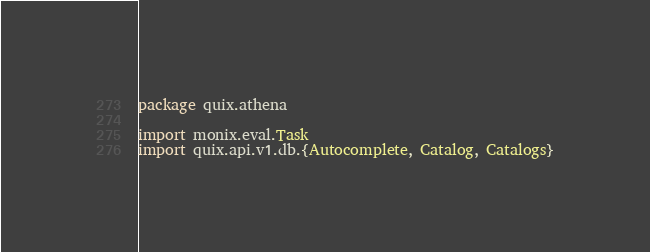<code> <loc_0><loc_0><loc_500><loc_500><_Scala_>package quix.athena

import monix.eval.Task
import quix.api.v1.db.{Autocomplete, Catalog, Catalogs}
</code> 